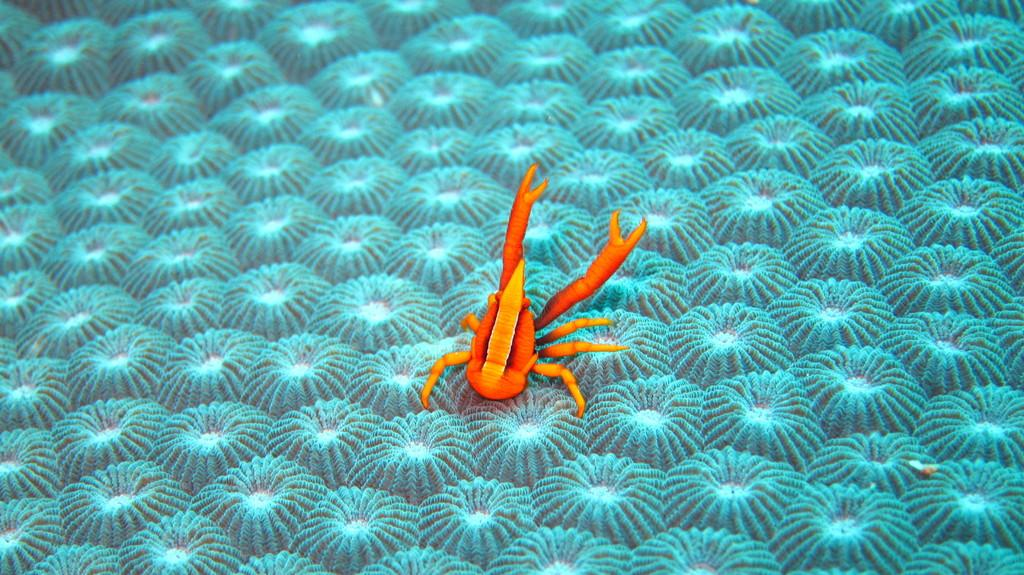What type of image is being described? The image appears to be animated. What animal is present in the image? There is a crab in the image. Where is the crab located in the image? The crab is in the front of the image. What can be seen at the bottom of the image? There are plants at the bottom of the image. What color is the crab in the image? The crab is orange in color. What type of wool is being used by the representative in the image? There is no representative or wool present in the image; it features an animated crab and plants. 